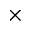Convert formula to latex. <formula><loc_0><loc_0><loc_500><loc_500>\times</formula> 